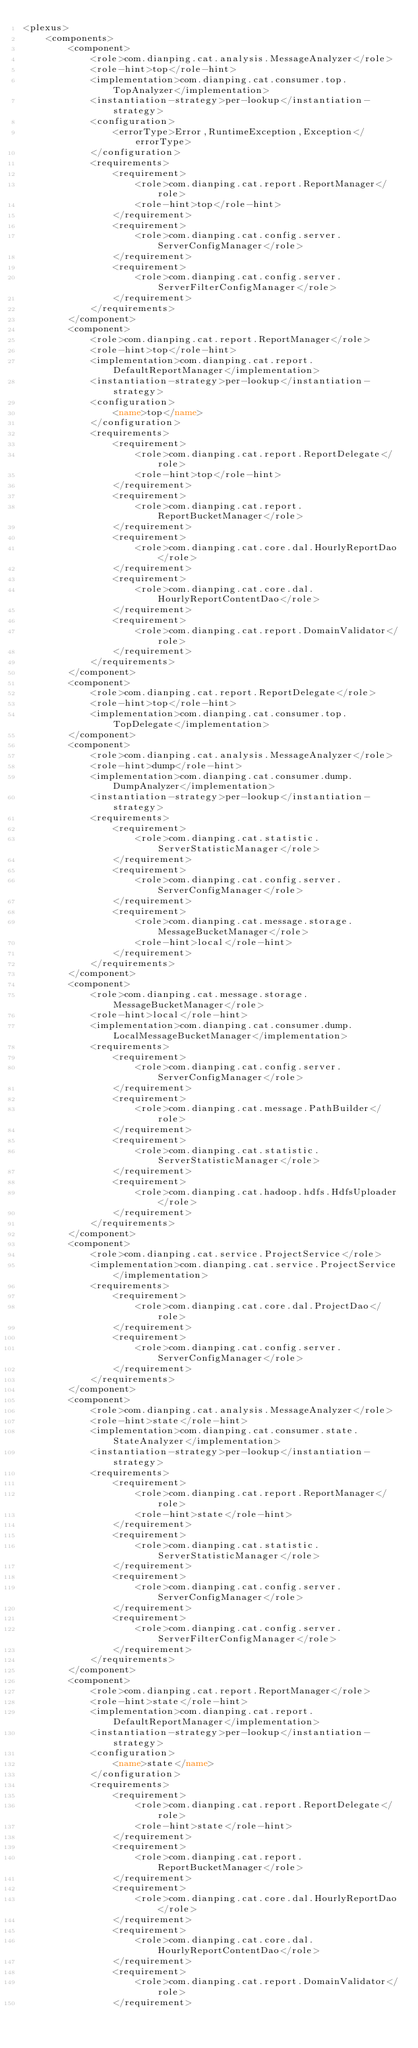<code> <loc_0><loc_0><loc_500><loc_500><_XML_><plexus>
	<components>
		<component>
			<role>com.dianping.cat.analysis.MessageAnalyzer</role>
			<role-hint>top</role-hint>
			<implementation>com.dianping.cat.consumer.top.TopAnalyzer</implementation>
			<instantiation-strategy>per-lookup</instantiation-strategy>
			<configuration>
				<errorType>Error,RuntimeException,Exception</errorType>
			</configuration>
			<requirements>
				<requirement>
					<role>com.dianping.cat.report.ReportManager</role>
					<role-hint>top</role-hint>
				</requirement>
				<requirement>
					<role>com.dianping.cat.config.server.ServerConfigManager</role>
				</requirement>
				<requirement>
					<role>com.dianping.cat.config.server.ServerFilterConfigManager</role>
				</requirement>
			</requirements>
		</component>
		<component>
			<role>com.dianping.cat.report.ReportManager</role>
			<role-hint>top</role-hint>
			<implementation>com.dianping.cat.report.DefaultReportManager</implementation>
			<instantiation-strategy>per-lookup</instantiation-strategy>
			<configuration>
				<name>top</name>
			</configuration>
			<requirements>
				<requirement>
					<role>com.dianping.cat.report.ReportDelegate</role>
					<role-hint>top</role-hint>
				</requirement>
				<requirement>
					<role>com.dianping.cat.report.ReportBucketManager</role>
				</requirement>
				<requirement>
					<role>com.dianping.cat.core.dal.HourlyReportDao</role>
				</requirement>
				<requirement>
					<role>com.dianping.cat.core.dal.HourlyReportContentDao</role>
				</requirement>
				<requirement>
					<role>com.dianping.cat.report.DomainValidator</role>
				</requirement>
			</requirements>
		</component>
		<component>
			<role>com.dianping.cat.report.ReportDelegate</role>
			<role-hint>top</role-hint>
			<implementation>com.dianping.cat.consumer.top.TopDelegate</implementation>
		</component>
		<component>
			<role>com.dianping.cat.analysis.MessageAnalyzer</role>
			<role-hint>dump</role-hint>
			<implementation>com.dianping.cat.consumer.dump.DumpAnalyzer</implementation>
			<instantiation-strategy>per-lookup</instantiation-strategy>
			<requirements>
				<requirement>
					<role>com.dianping.cat.statistic.ServerStatisticManager</role>
				</requirement>
				<requirement>
					<role>com.dianping.cat.config.server.ServerConfigManager</role>
				</requirement>
				<requirement>
					<role>com.dianping.cat.message.storage.MessageBucketManager</role>
					<role-hint>local</role-hint>
				</requirement>
			</requirements>
		</component>
		<component>
			<role>com.dianping.cat.message.storage.MessageBucketManager</role>
			<role-hint>local</role-hint>
			<implementation>com.dianping.cat.consumer.dump.LocalMessageBucketManager</implementation>
			<requirements>
				<requirement>
					<role>com.dianping.cat.config.server.ServerConfigManager</role>
				</requirement>
				<requirement>
					<role>com.dianping.cat.message.PathBuilder</role>
				</requirement>
				<requirement>
					<role>com.dianping.cat.statistic.ServerStatisticManager</role>
				</requirement>
				<requirement>
					<role>com.dianping.cat.hadoop.hdfs.HdfsUploader</role>
				</requirement>
			</requirements>
		</component>
		<component>
			<role>com.dianping.cat.service.ProjectService</role>
			<implementation>com.dianping.cat.service.ProjectService</implementation>
			<requirements>
				<requirement>
					<role>com.dianping.cat.core.dal.ProjectDao</role>
				</requirement>
				<requirement>
					<role>com.dianping.cat.config.server.ServerConfigManager</role>
				</requirement>
			</requirements>
		</component>
		<component>
			<role>com.dianping.cat.analysis.MessageAnalyzer</role>
			<role-hint>state</role-hint>
			<implementation>com.dianping.cat.consumer.state.StateAnalyzer</implementation>
			<instantiation-strategy>per-lookup</instantiation-strategy>
			<requirements>
				<requirement>
					<role>com.dianping.cat.report.ReportManager</role>
					<role-hint>state</role-hint>
				</requirement>
				<requirement>
					<role>com.dianping.cat.statistic.ServerStatisticManager</role>
				</requirement>
				<requirement>
					<role>com.dianping.cat.config.server.ServerConfigManager</role>
				</requirement>
				<requirement>
					<role>com.dianping.cat.config.server.ServerFilterConfigManager</role>
				</requirement>
			</requirements>
		</component>
		<component>
			<role>com.dianping.cat.report.ReportManager</role>
			<role-hint>state</role-hint>
			<implementation>com.dianping.cat.report.DefaultReportManager</implementation>
			<instantiation-strategy>per-lookup</instantiation-strategy>
			<configuration>
				<name>state</name>
			</configuration>
			<requirements>
				<requirement>
					<role>com.dianping.cat.report.ReportDelegate</role>
					<role-hint>state</role-hint>
				</requirement>
				<requirement>
					<role>com.dianping.cat.report.ReportBucketManager</role>
				</requirement>
				<requirement>
					<role>com.dianping.cat.core.dal.HourlyReportDao</role>
				</requirement>
				<requirement>
					<role>com.dianping.cat.core.dal.HourlyReportContentDao</role>
				</requirement>
				<requirement>
					<role>com.dianping.cat.report.DomainValidator</role>
				</requirement></code> 